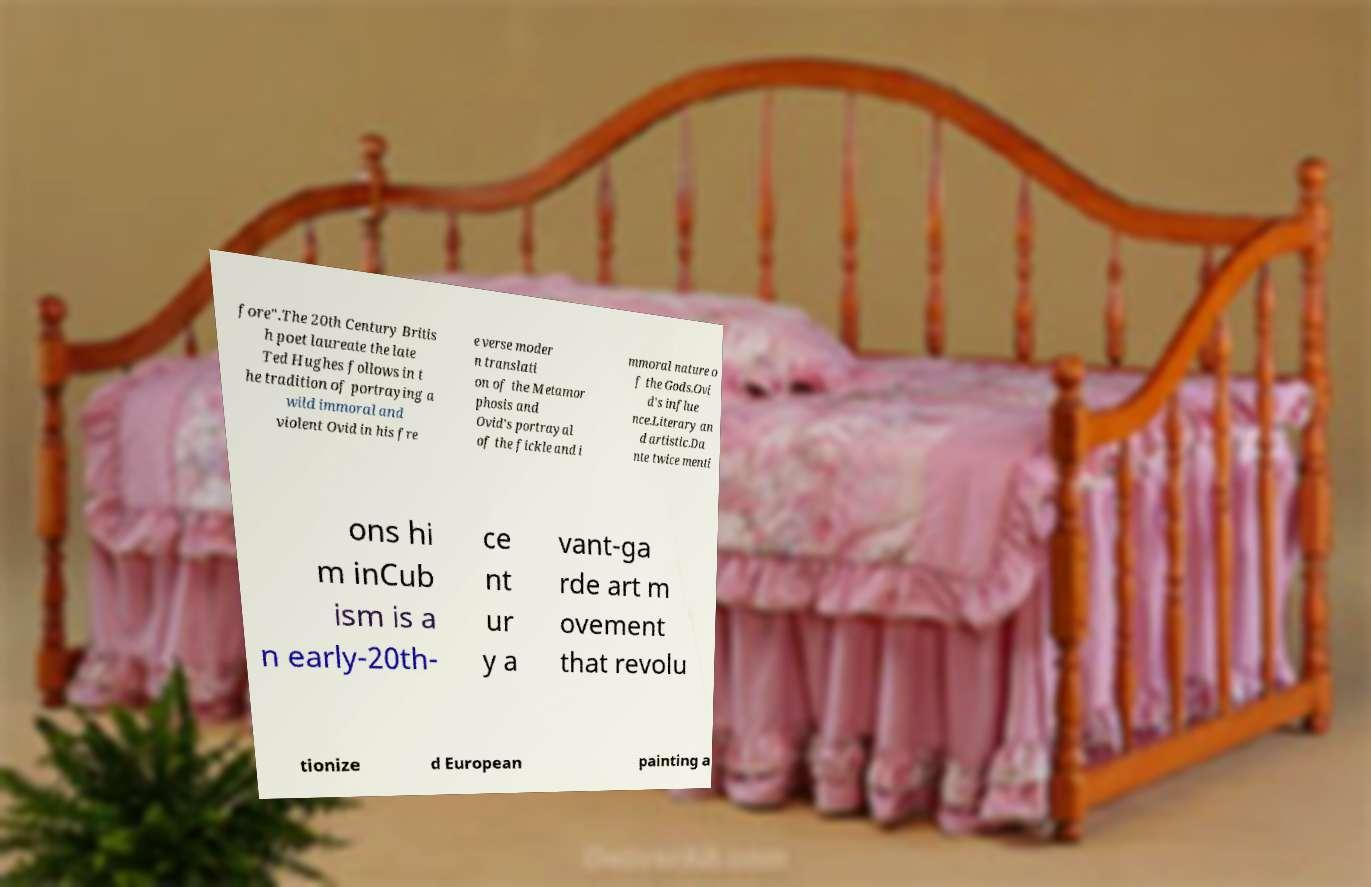I need the written content from this picture converted into text. Can you do that? fore".The 20th Century Britis h poet laureate the late Ted Hughes follows in t he tradition of portraying a wild immoral and violent Ovid in his fre e verse moder n translati on of the Metamor phosis and Ovid's portrayal of the fickle and i mmoral nature o f the Gods.Ovi d's influe nce.Literary an d artistic.Da nte twice menti ons hi m inCub ism is a n early-20th- ce nt ur y a vant-ga rde art m ovement that revolu tionize d European painting a 